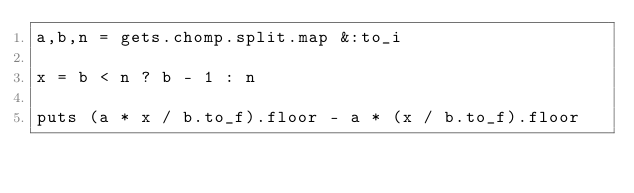Convert code to text. <code><loc_0><loc_0><loc_500><loc_500><_Ruby_>a,b,n = gets.chomp.split.map &:to_i
 
x = b < n ? b - 1 : n
 
puts (a * x / b.to_f).floor - a * (x / b.to_f).floor</code> 